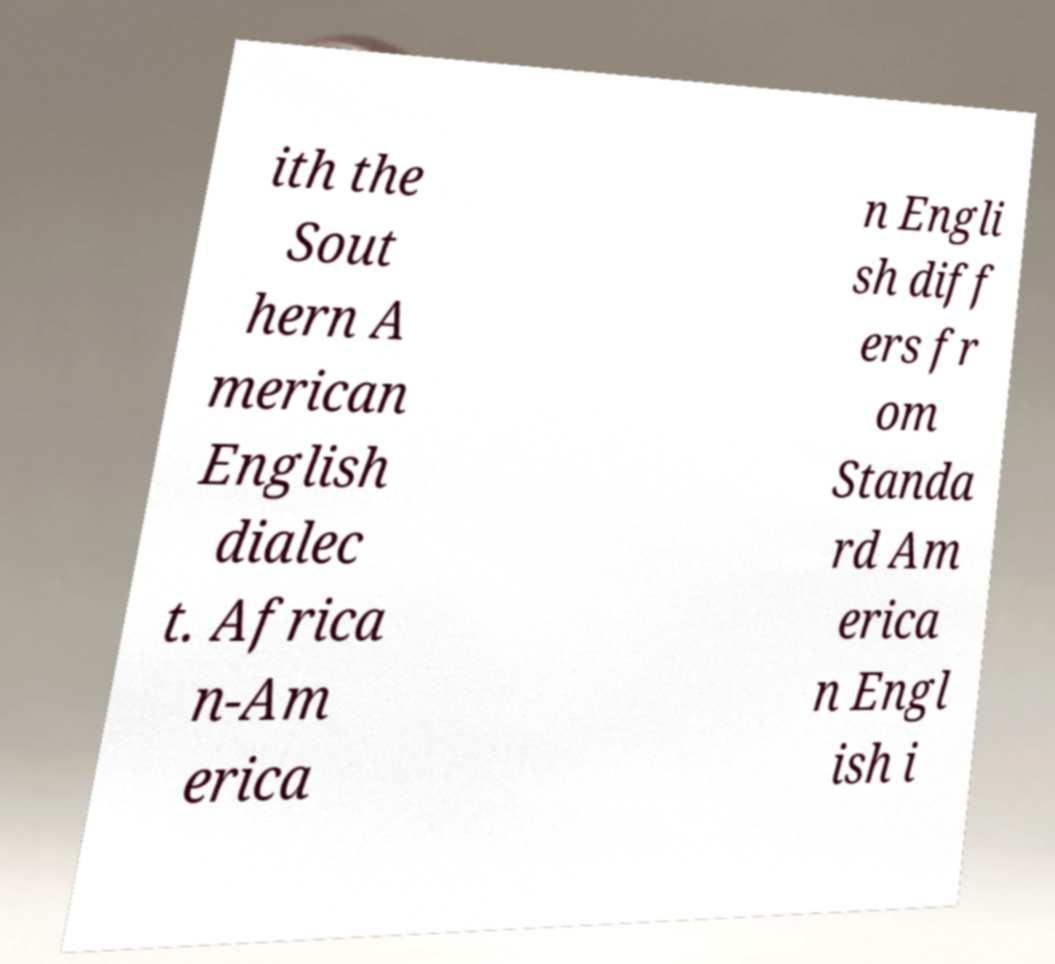Please identify and transcribe the text found in this image. ith the Sout hern A merican English dialec t. Africa n-Am erica n Engli sh diff ers fr om Standa rd Am erica n Engl ish i 